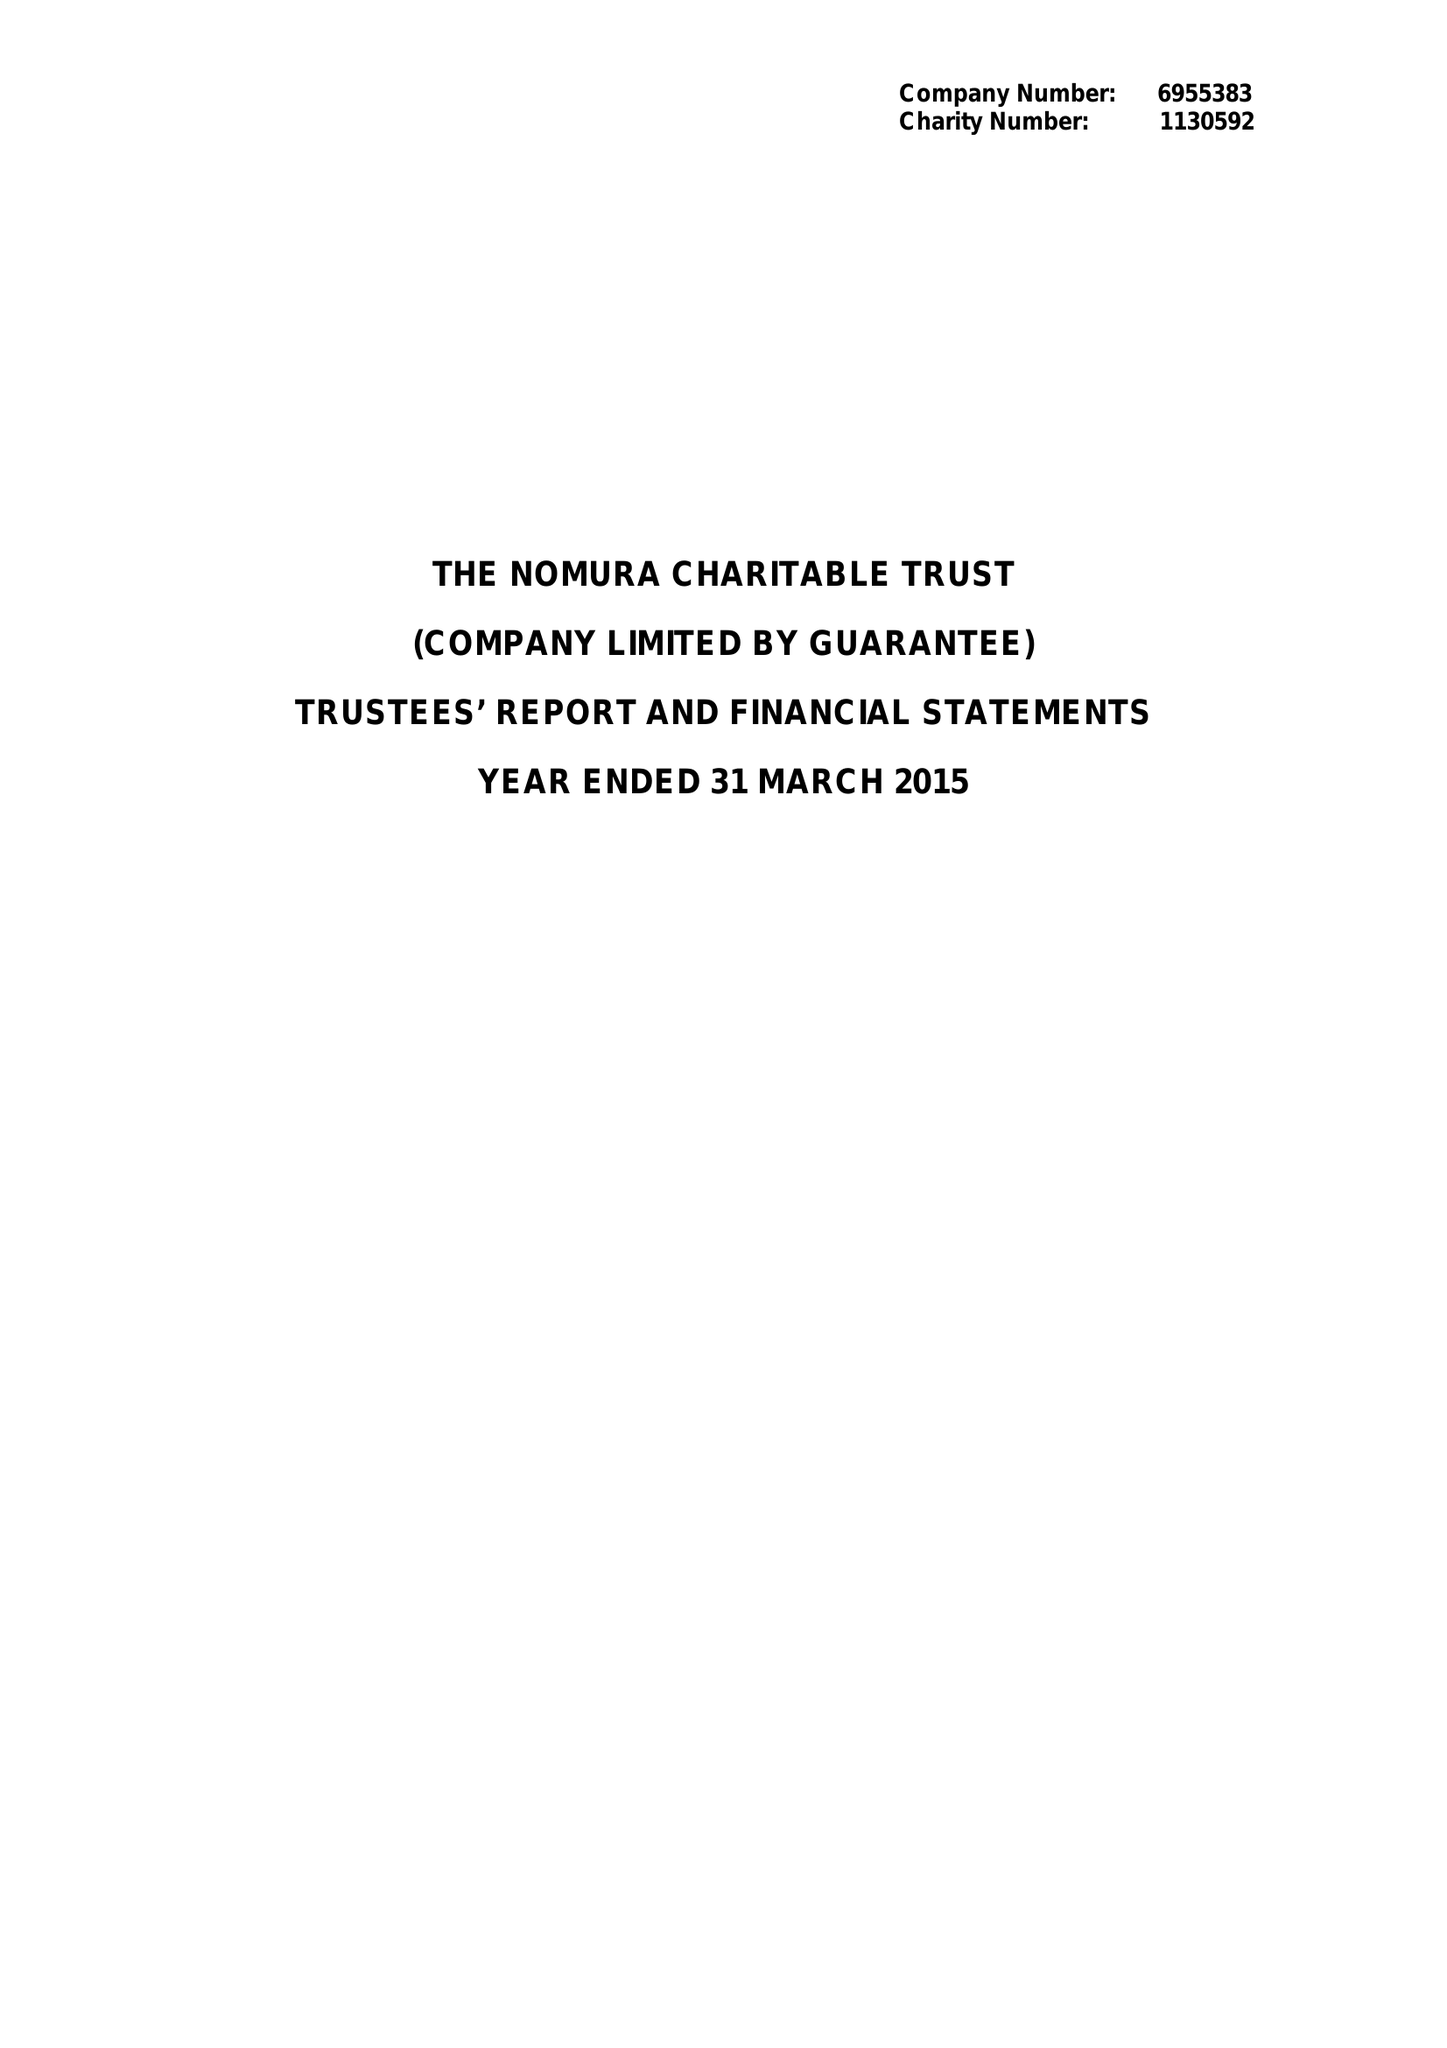What is the value for the report_date?
Answer the question using a single word or phrase. 2015-03-31 